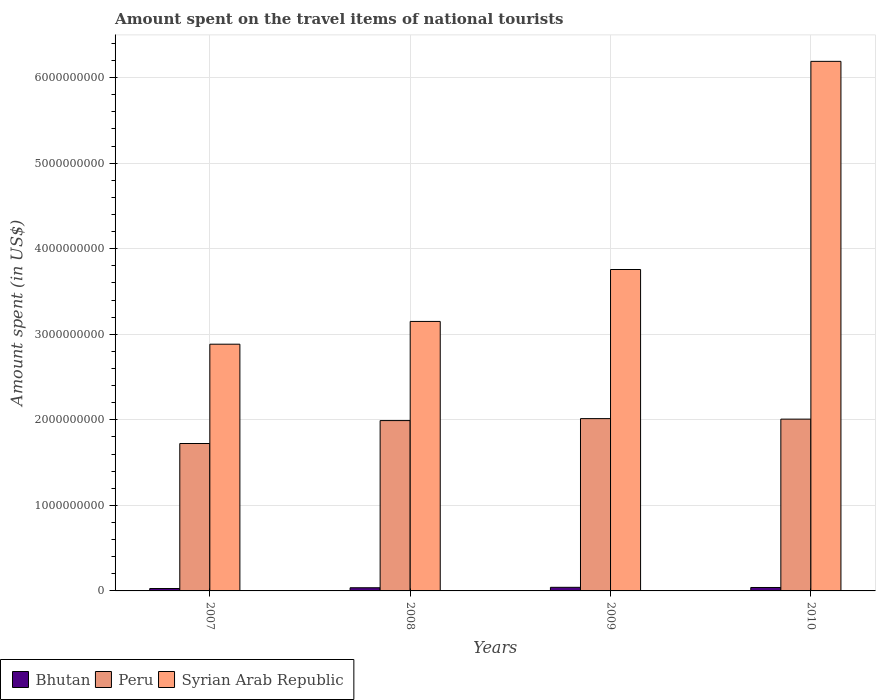How many groups of bars are there?
Make the answer very short. 4. Are the number of bars per tick equal to the number of legend labels?
Keep it short and to the point. Yes. Are the number of bars on each tick of the X-axis equal?
Offer a very short reply. Yes. What is the label of the 3rd group of bars from the left?
Your answer should be compact. 2009. In how many cases, is the number of bars for a given year not equal to the number of legend labels?
Provide a succinct answer. 0. What is the amount spent on the travel items of national tourists in Syrian Arab Republic in 2008?
Provide a short and direct response. 3.15e+09. Across all years, what is the maximum amount spent on the travel items of national tourists in Syrian Arab Republic?
Your answer should be very brief. 6.19e+09. Across all years, what is the minimum amount spent on the travel items of national tourists in Syrian Arab Republic?
Provide a short and direct response. 2.88e+09. What is the total amount spent on the travel items of national tourists in Bhutan in the graph?
Offer a terse response. 1.47e+08. What is the difference between the amount spent on the travel items of national tourists in Syrian Arab Republic in 2008 and that in 2010?
Give a very brief answer. -3.04e+09. What is the difference between the amount spent on the travel items of national tourists in Peru in 2007 and the amount spent on the travel items of national tourists in Syrian Arab Republic in 2008?
Your answer should be compact. -1.43e+09. What is the average amount spent on the travel items of national tourists in Syrian Arab Republic per year?
Keep it short and to the point. 4.00e+09. In the year 2010, what is the difference between the amount spent on the travel items of national tourists in Syrian Arab Republic and amount spent on the travel items of national tourists in Peru?
Provide a succinct answer. 4.18e+09. In how many years, is the amount spent on the travel items of national tourists in Peru greater than 400000000 US$?
Your answer should be compact. 4. What is the ratio of the amount spent on the travel items of national tourists in Peru in 2007 to that in 2009?
Your answer should be very brief. 0.86. Is the amount spent on the travel items of national tourists in Peru in 2008 less than that in 2010?
Make the answer very short. Yes. Is the difference between the amount spent on the travel items of national tourists in Syrian Arab Republic in 2009 and 2010 greater than the difference between the amount spent on the travel items of national tourists in Peru in 2009 and 2010?
Provide a short and direct response. No. What is the difference between the highest and the lowest amount spent on the travel items of national tourists in Peru?
Provide a succinct answer. 2.91e+08. In how many years, is the amount spent on the travel items of national tourists in Syrian Arab Republic greater than the average amount spent on the travel items of national tourists in Syrian Arab Republic taken over all years?
Your answer should be compact. 1. What does the 1st bar from the left in 2007 represents?
Offer a very short reply. Bhutan. How many bars are there?
Ensure brevity in your answer.  12. Are the values on the major ticks of Y-axis written in scientific E-notation?
Offer a very short reply. No. Where does the legend appear in the graph?
Give a very brief answer. Bottom left. How many legend labels are there?
Your answer should be compact. 3. How are the legend labels stacked?
Your answer should be very brief. Horizontal. What is the title of the graph?
Your response must be concise. Amount spent on the travel items of national tourists. What is the label or title of the X-axis?
Your response must be concise. Years. What is the label or title of the Y-axis?
Make the answer very short. Amount spent (in US$). What is the Amount spent (in US$) of Bhutan in 2007?
Keep it short and to the point. 2.80e+07. What is the Amount spent (in US$) of Peru in 2007?
Give a very brief answer. 1.72e+09. What is the Amount spent (in US$) in Syrian Arab Republic in 2007?
Your answer should be very brief. 2.88e+09. What is the Amount spent (in US$) of Bhutan in 2008?
Your answer should be compact. 3.70e+07. What is the Amount spent (in US$) in Peru in 2008?
Give a very brief answer. 1.99e+09. What is the Amount spent (in US$) of Syrian Arab Republic in 2008?
Offer a terse response. 3.15e+09. What is the Amount spent (in US$) in Bhutan in 2009?
Provide a short and direct response. 4.20e+07. What is the Amount spent (in US$) of Peru in 2009?
Ensure brevity in your answer.  2.01e+09. What is the Amount spent (in US$) of Syrian Arab Republic in 2009?
Keep it short and to the point. 3.76e+09. What is the Amount spent (in US$) of Bhutan in 2010?
Offer a terse response. 4.00e+07. What is the Amount spent (in US$) in Peru in 2010?
Provide a succinct answer. 2.01e+09. What is the Amount spent (in US$) in Syrian Arab Republic in 2010?
Ensure brevity in your answer.  6.19e+09. Across all years, what is the maximum Amount spent (in US$) of Bhutan?
Offer a very short reply. 4.20e+07. Across all years, what is the maximum Amount spent (in US$) in Peru?
Offer a very short reply. 2.01e+09. Across all years, what is the maximum Amount spent (in US$) of Syrian Arab Republic?
Ensure brevity in your answer.  6.19e+09. Across all years, what is the minimum Amount spent (in US$) of Bhutan?
Offer a terse response. 2.80e+07. Across all years, what is the minimum Amount spent (in US$) in Peru?
Your response must be concise. 1.72e+09. Across all years, what is the minimum Amount spent (in US$) in Syrian Arab Republic?
Your answer should be very brief. 2.88e+09. What is the total Amount spent (in US$) of Bhutan in the graph?
Provide a succinct answer. 1.47e+08. What is the total Amount spent (in US$) of Peru in the graph?
Your answer should be compact. 7.74e+09. What is the total Amount spent (in US$) in Syrian Arab Republic in the graph?
Offer a very short reply. 1.60e+1. What is the difference between the Amount spent (in US$) of Bhutan in 2007 and that in 2008?
Ensure brevity in your answer.  -9.00e+06. What is the difference between the Amount spent (in US$) in Peru in 2007 and that in 2008?
Give a very brief answer. -2.68e+08. What is the difference between the Amount spent (in US$) of Syrian Arab Republic in 2007 and that in 2008?
Give a very brief answer. -2.66e+08. What is the difference between the Amount spent (in US$) of Bhutan in 2007 and that in 2009?
Offer a terse response. -1.40e+07. What is the difference between the Amount spent (in US$) in Peru in 2007 and that in 2009?
Give a very brief answer. -2.91e+08. What is the difference between the Amount spent (in US$) of Syrian Arab Republic in 2007 and that in 2009?
Your answer should be compact. -8.73e+08. What is the difference between the Amount spent (in US$) in Bhutan in 2007 and that in 2010?
Your answer should be very brief. -1.20e+07. What is the difference between the Amount spent (in US$) in Peru in 2007 and that in 2010?
Your answer should be very brief. -2.85e+08. What is the difference between the Amount spent (in US$) in Syrian Arab Republic in 2007 and that in 2010?
Ensure brevity in your answer.  -3.31e+09. What is the difference between the Amount spent (in US$) of Bhutan in 2008 and that in 2009?
Your response must be concise. -5.00e+06. What is the difference between the Amount spent (in US$) in Peru in 2008 and that in 2009?
Keep it short and to the point. -2.30e+07. What is the difference between the Amount spent (in US$) of Syrian Arab Republic in 2008 and that in 2009?
Offer a terse response. -6.07e+08. What is the difference between the Amount spent (in US$) of Peru in 2008 and that in 2010?
Ensure brevity in your answer.  -1.70e+07. What is the difference between the Amount spent (in US$) in Syrian Arab Republic in 2008 and that in 2010?
Provide a succinct answer. -3.04e+09. What is the difference between the Amount spent (in US$) in Bhutan in 2009 and that in 2010?
Your answer should be very brief. 2.00e+06. What is the difference between the Amount spent (in US$) of Peru in 2009 and that in 2010?
Your answer should be compact. 6.00e+06. What is the difference between the Amount spent (in US$) of Syrian Arab Republic in 2009 and that in 2010?
Your answer should be compact. -2.43e+09. What is the difference between the Amount spent (in US$) of Bhutan in 2007 and the Amount spent (in US$) of Peru in 2008?
Offer a very short reply. -1.96e+09. What is the difference between the Amount spent (in US$) in Bhutan in 2007 and the Amount spent (in US$) in Syrian Arab Republic in 2008?
Keep it short and to the point. -3.12e+09. What is the difference between the Amount spent (in US$) of Peru in 2007 and the Amount spent (in US$) of Syrian Arab Republic in 2008?
Make the answer very short. -1.43e+09. What is the difference between the Amount spent (in US$) in Bhutan in 2007 and the Amount spent (in US$) in Peru in 2009?
Your answer should be very brief. -1.99e+09. What is the difference between the Amount spent (in US$) of Bhutan in 2007 and the Amount spent (in US$) of Syrian Arab Republic in 2009?
Offer a terse response. -3.73e+09. What is the difference between the Amount spent (in US$) in Peru in 2007 and the Amount spent (in US$) in Syrian Arab Republic in 2009?
Your response must be concise. -2.03e+09. What is the difference between the Amount spent (in US$) of Bhutan in 2007 and the Amount spent (in US$) of Peru in 2010?
Your response must be concise. -1.98e+09. What is the difference between the Amount spent (in US$) in Bhutan in 2007 and the Amount spent (in US$) in Syrian Arab Republic in 2010?
Your answer should be very brief. -6.16e+09. What is the difference between the Amount spent (in US$) in Peru in 2007 and the Amount spent (in US$) in Syrian Arab Republic in 2010?
Your answer should be compact. -4.47e+09. What is the difference between the Amount spent (in US$) in Bhutan in 2008 and the Amount spent (in US$) in Peru in 2009?
Offer a very short reply. -1.98e+09. What is the difference between the Amount spent (in US$) in Bhutan in 2008 and the Amount spent (in US$) in Syrian Arab Republic in 2009?
Keep it short and to the point. -3.72e+09. What is the difference between the Amount spent (in US$) of Peru in 2008 and the Amount spent (in US$) of Syrian Arab Republic in 2009?
Offer a very short reply. -1.77e+09. What is the difference between the Amount spent (in US$) of Bhutan in 2008 and the Amount spent (in US$) of Peru in 2010?
Your answer should be compact. -1.97e+09. What is the difference between the Amount spent (in US$) in Bhutan in 2008 and the Amount spent (in US$) in Syrian Arab Republic in 2010?
Your answer should be compact. -6.15e+09. What is the difference between the Amount spent (in US$) of Peru in 2008 and the Amount spent (in US$) of Syrian Arab Republic in 2010?
Your answer should be compact. -4.20e+09. What is the difference between the Amount spent (in US$) in Bhutan in 2009 and the Amount spent (in US$) in Peru in 2010?
Your response must be concise. -1.97e+09. What is the difference between the Amount spent (in US$) of Bhutan in 2009 and the Amount spent (in US$) of Syrian Arab Republic in 2010?
Give a very brief answer. -6.15e+09. What is the difference between the Amount spent (in US$) in Peru in 2009 and the Amount spent (in US$) in Syrian Arab Republic in 2010?
Make the answer very short. -4.18e+09. What is the average Amount spent (in US$) of Bhutan per year?
Provide a succinct answer. 3.68e+07. What is the average Amount spent (in US$) in Peru per year?
Ensure brevity in your answer.  1.93e+09. What is the average Amount spent (in US$) in Syrian Arab Republic per year?
Your answer should be very brief. 4.00e+09. In the year 2007, what is the difference between the Amount spent (in US$) in Bhutan and Amount spent (in US$) in Peru?
Make the answer very short. -1.70e+09. In the year 2007, what is the difference between the Amount spent (in US$) in Bhutan and Amount spent (in US$) in Syrian Arab Republic?
Make the answer very short. -2.86e+09. In the year 2007, what is the difference between the Amount spent (in US$) of Peru and Amount spent (in US$) of Syrian Arab Republic?
Your answer should be compact. -1.16e+09. In the year 2008, what is the difference between the Amount spent (in US$) in Bhutan and Amount spent (in US$) in Peru?
Provide a short and direct response. -1.95e+09. In the year 2008, what is the difference between the Amount spent (in US$) of Bhutan and Amount spent (in US$) of Syrian Arab Republic?
Provide a succinct answer. -3.11e+09. In the year 2008, what is the difference between the Amount spent (in US$) in Peru and Amount spent (in US$) in Syrian Arab Republic?
Your answer should be very brief. -1.16e+09. In the year 2009, what is the difference between the Amount spent (in US$) of Bhutan and Amount spent (in US$) of Peru?
Your answer should be compact. -1.97e+09. In the year 2009, what is the difference between the Amount spent (in US$) of Bhutan and Amount spent (in US$) of Syrian Arab Republic?
Your response must be concise. -3.72e+09. In the year 2009, what is the difference between the Amount spent (in US$) in Peru and Amount spent (in US$) in Syrian Arab Republic?
Your response must be concise. -1.74e+09. In the year 2010, what is the difference between the Amount spent (in US$) of Bhutan and Amount spent (in US$) of Peru?
Offer a very short reply. -1.97e+09. In the year 2010, what is the difference between the Amount spent (in US$) of Bhutan and Amount spent (in US$) of Syrian Arab Republic?
Your response must be concise. -6.15e+09. In the year 2010, what is the difference between the Amount spent (in US$) in Peru and Amount spent (in US$) in Syrian Arab Republic?
Make the answer very short. -4.18e+09. What is the ratio of the Amount spent (in US$) in Bhutan in 2007 to that in 2008?
Your answer should be very brief. 0.76. What is the ratio of the Amount spent (in US$) in Peru in 2007 to that in 2008?
Make the answer very short. 0.87. What is the ratio of the Amount spent (in US$) in Syrian Arab Republic in 2007 to that in 2008?
Your answer should be very brief. 0.92. What is the ratio of the Amount spent (in US$) of Peru in 2007 to that in 2009?
Your response must be concise. 0.86. What is the ratio of the Amount spent (in US$) of Syrian Arab Republic in 2007 to that in 2009?
Offer a very short reply. 0.77. What is the ratio of the Amount spent (in US$) in Peru in 2007 to that in 2010?
Provide a short and direct response. 0.86. What is the ratio of the Amount spent (in US$) in Syrian Arab Republic in 2007 to that in 2010?
Provide a succinct answer. 0.47. What is the ratio of the Amount spent (in US$) in Bhutan in 2008 to that in 2009?
Offer a terse response. 0.88. What is the ratio of the Amount spent (in US$) in Peru in 2008 to that in 2009?
Your response must be concise. 0.99. What is the ratio of the Amount spent (in US$) in Syrian Arab Republic in 2008 to that in 2009?
Your answer should be very brief. 0.84. What is the ratio of the Amount spent (in US$) of Bhutan in 2008 to that in 2010?
Keep it short and to the point. 0.93. What is the ratio of the Amount spent (in US$) in Peru in 2008 to that in 2010?
Offer a terse response. 0.99. What is the ratio of the Amount spent (in US$) in Syrian Arab Republic in 2008 to that in 2010?
Offer a terse response. 0.51. What is the ratio of the Amount spent (in US$) in Peru in 2009 to that in 2010?
Your response must be concise. 1. What is the ratio of the Amount spent (in US$) in Syrian Arab Republic in 2009 to that in 2010?
Your answer should be very brief. 0.61. What is the difference between the highest and the second highest Amount spent (in US$) in Bhutan?
Give a very brief answer. 2.00e+06. What is the difference between the highest and the second highest Amount spent (in US$) of Syrian Arab Republic?
Give a very brief answer. 2.43e+09. What is the difference between the highest and the lowest Amount spent (in US$) of Bhutan?
Ensure brevity in your answer.  1.40e+07. What is the difference between the highest and the lowest Amount spent (in US$) of Peru?
Your response must be concise. 2.91e+08. What is the difference between the highest and the lowest Amount spent (in US$) in Syrian Arab Republic?
Provide a short and direct response. 3.31e+09. 